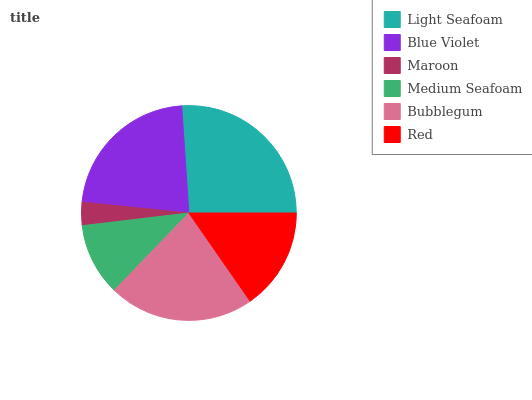Is Maroon the minimum?
Answer yes or no. Yes. Is Light Seafoam the maximum?
Answer yes or no. Yes. Is Blue Violet the minimum?
Answer yes or no. No. Is Blue Violet the maximum?
Answer yes or no. No. Is Light Seafoam greater than Blue Violet?
Answer yes or no. Yes. Is Blue Violet less than Light Seafoam?
Answer yes or no. Yes. Is Blue Violet greater than Light Seafoam?
Answer yes or no. No. Is Light Seafoam less than Blue Violet?
Answer yes or no. No. Is Bubblegum the high median?
Answer yes or no. Yes. Is Red the low median?
Answer yes or no. Yes. Is Maroon the high median?
Answer yes or no. No. Is Medium Seafoam the low median?
Answer yes or no. No. 